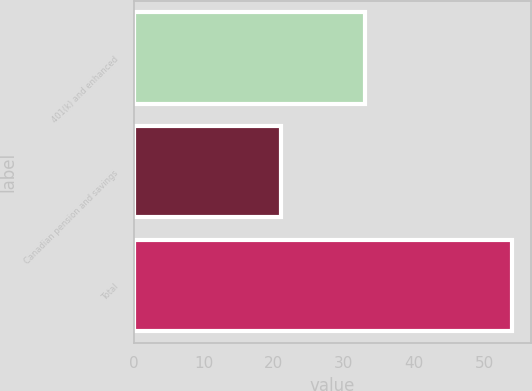<chart> <loc_0><loc_0><loc_500><loc_500><bar_chart><fcel>401(k) and enhanced<fcel>Canadian pension and savings<fcel>Total<nl><fcel>33<fcel>21<fcel>54<nl></chart> 